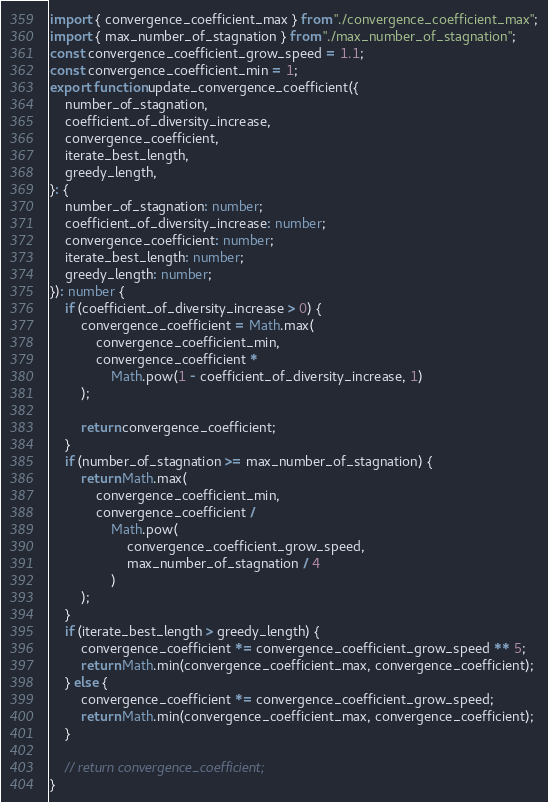Convert code to text. <code><loc_0><loc_0><loc_500><loc_500><_TypeScript_>import { convergence_coefficient_max } from "./convergence_coefficient_max";
import { max_number_of_stagnation } from "./max_number_of_stagnation";
const convergence_coefficient_grow_speed = 1.1;
const convergence_coefficient_min = 1;
export function update_convergence_coefficient({
    number_of_stagnation,
    coefficient_of_diversity_increase,
    convergence_coefficient,
    iterate_best_length,
    greedy_length,
}: {
    number_of_stagnation: number;
    coefficient_of_diversity_increase: number;
    convergence_coefficient: number;
    iterate_best_length: number;
    greedy_length: number;
}): number {
    if (coefficient_of_diversity_increase > 0) {
        convergence_coefficient = Math.max(
            convergence_coefficient_min,
            convergence_coefficient *
                Math.pow(1 - coefficient_of_diversity_increase, 1)
        );

        return convergence_coefficient;
    }
    if (number_of_stagnation >= max_number_of_stagnation) {
        return Math.max(
            convergence_coefficient_min,
            convergence_coefficient /
                Math.pow(
                    convergence_coefficient_grow_speed,
                    max_number_of_stagnation / 4
                )
        );
    }
    if (iterate_best_length > greedy_length) {
        convergence_coefficient *= convergence_coefficient_grow_speed ** 5;
        return Math.min(convergence_coefficient_max, convergence_coefficient);
    } else {
        convergence_coefficient *= convergence_coefficient_grow_speed;
        return Math.min(convergence_coefficient_max, convergence_coefficient);
    }

    // return convergence_coefficient;
}
</code> 